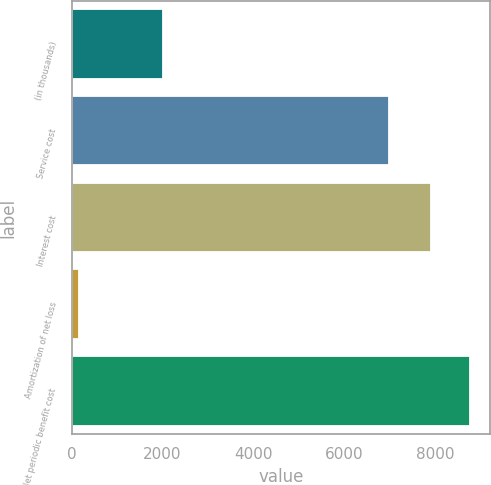Convert chart. <chart><loc_0><loc_0><loc_500><loc_500><bar_chart><fcel>(in thousands)<fcel>Service cost<fcel>Interest cost<fcel>Amortization of net loss<fcel>Net periodic benefit cost<nl><fcel>2008<fcel>6980<fcel>7910<fcel>155<fcel>8765.4<nl></chart> 